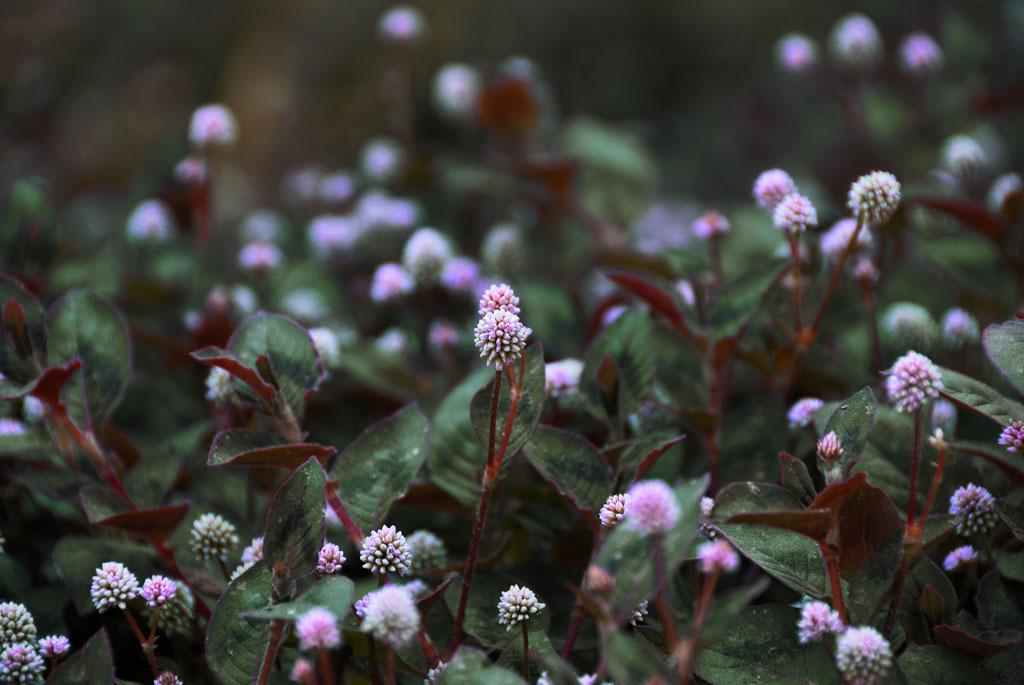What type of vegetation is present in the image? There are green leaves in the image. What color are the flowers on the stems in the image? The flowers on the stems are pink in color. Are there any other flowers visible in the image? Yes, there are white color flowers in the image. How would you describe the background of the image? The background of the image is blurred. How does the cloud in the image compare to the flowers? There is no cloud present in the image, so it cannot be compared to the flowers. 